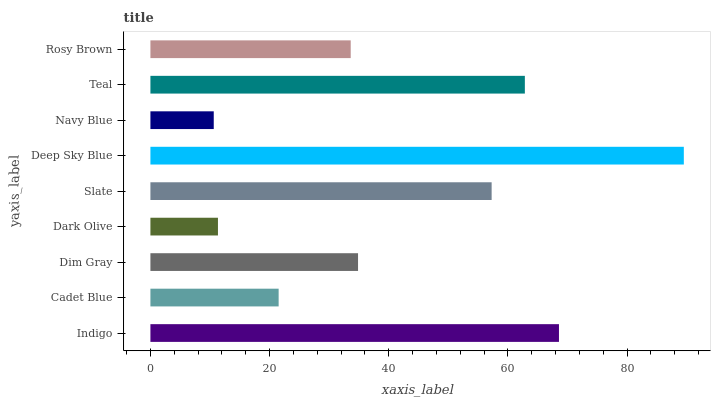Is Navy Blue the minimum?
Answer yes or no. Yes. Is Deep Sky Blue the maximum?
Answer yes or no. Yes. Is Cadet Blue the minimum?
Answer yes or no. No. Is Cadet Blue the maximum?
Answer yes or no. No. Is Indigo greater than Cadet Blue?
Answer yes or no. Yes. Is Cadet Blue less than Indigo?
Answer yes or no. Yes. Is Cadet Blue greater than Indigo?
Answer yes or no. No. Is Indigo less than Cadet Blue?
Answer yes or no. No. Is Dim Gray the high median?
Answer yes or no. Yes. Is Dim Gray the low median?
Answer yes or no. Yes. Is Navy Blue the high median?
Answer yes or no. No. Is Teal the low median?
Answer yes or no. No. 